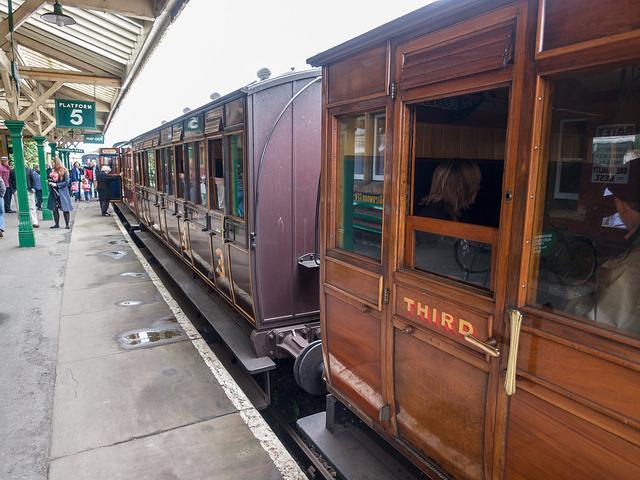How many people can be seen?
Give a very brief answer. 2. How many trains are visible?
Give a very brief answer. 1. How many benches are there?
Give a very brief answer. 0. 